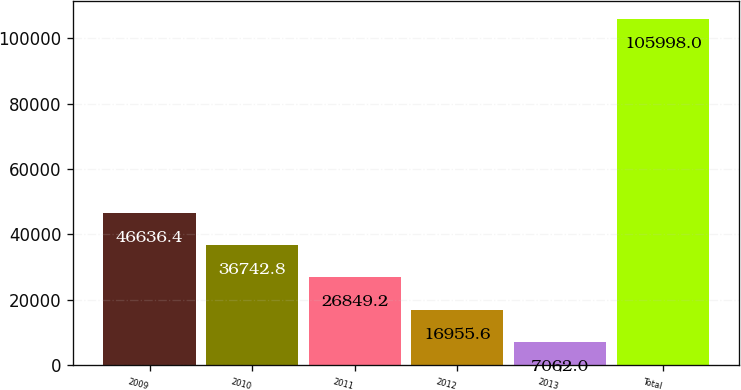Convert chart to OTSL. <chart><loc_0><loc_0><loc_500><loc_500><bar_chart><fcel>2009<fcel>2010<fcel>2011<fcel>2012<fcel>2013<fcel>Total<nl><fcel>46636.4<fcel>36742.8<fcel>26849.2<fcel>16955.6<fcel>7062<fcel>105998<nl></chart> 